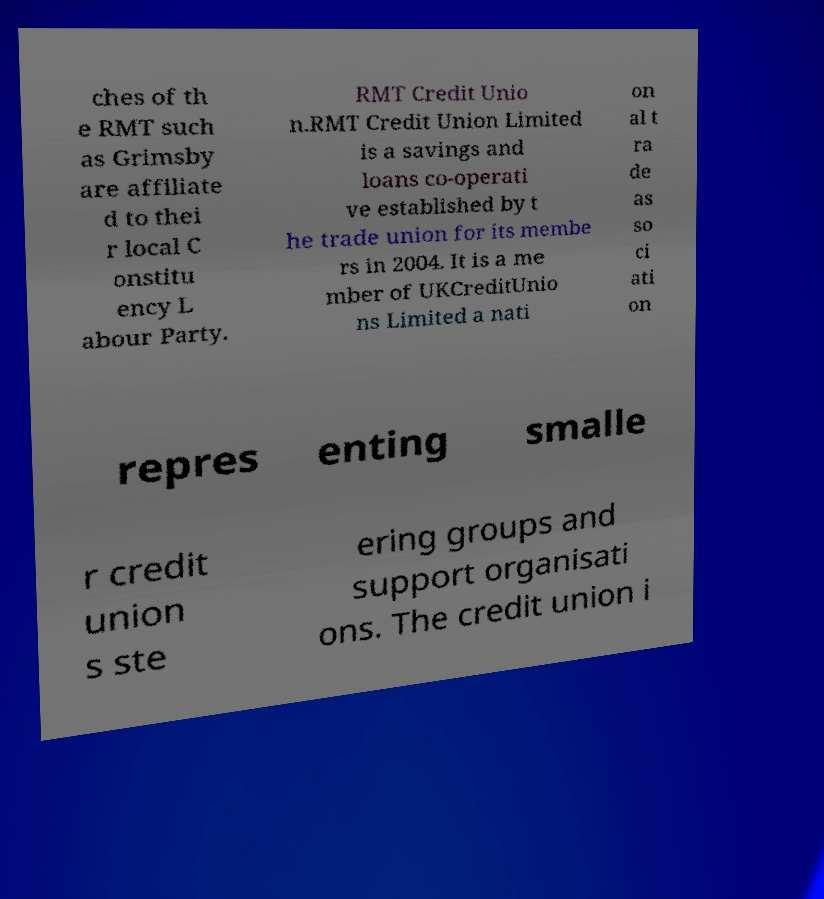Can you read and provide the text displayed in the image?This photo seems to have some interesting text. Can you extract and type it out for me? ches of th e RMT such as Grimsby are affiliate d to thei r local C onstitu ency L abour Party. RMT Credit Unio n.RMT Credit Union Limited is a savings and loans co-operati ve established by t he trade union for its membe rs in 2004. It is a me mber of UKCreditUnio ns Limited a nati on al t ra de as so ci ati on repres enting smalle r credit union s ste ering groups and support organisati ons. The credit union i 